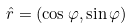Convert formula to latex. <formula><loc_0><loc_0><loc_500><loc_500>\hat { r } = ( \cos \varphi , \sin \varphi )</formula> 